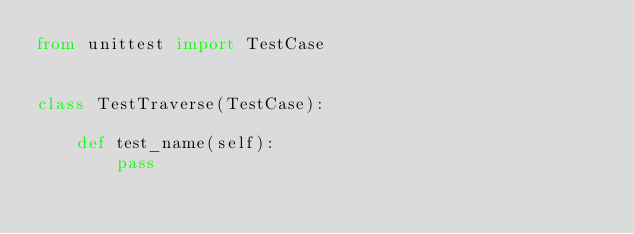Convert code to text. <code><loc_0><loc_0><loc_500><loc_500><_Python_>from unittest import TestCase


class TestTraverse(TestCase):

    def test_name(self):
        pass
</code> 